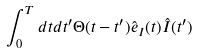<formula> <loc_0><loc_0><loc_500><loc_500>\int ^ { T } _ { 0 } d t d t ^ { \prime } \Theta ( t - t ^ { \prime } ) \hat { e } _ { I } ( t ) \hat { I } ( t ^ { \prime } )</formula> 